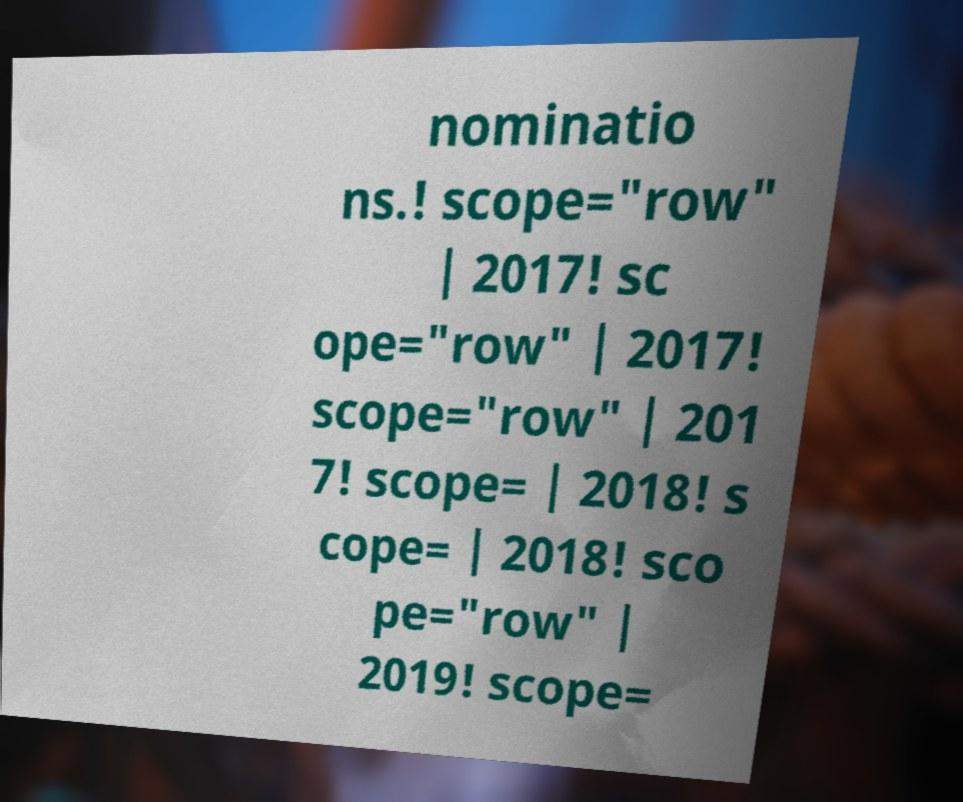Could you extract and type out the text from this image? nominatio ns.! scope="row" | 2017! sc ope="row" | 2017! scope="row" | 201 7! scope= | 2018! s cope= | 2018! sco pe="row" | 2019! scope= 